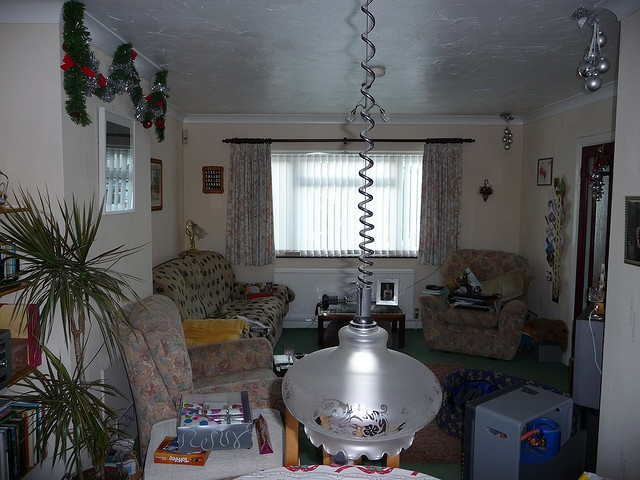Describe the objects in this image and their specific colors. I can see potted plant in gray and black tones, chair in gray and black tones, chair in gray, black, and darkblue tones, couch in gray and black tones, and dining table in gray, darkgray, lightgray, and brown tones in this image. 